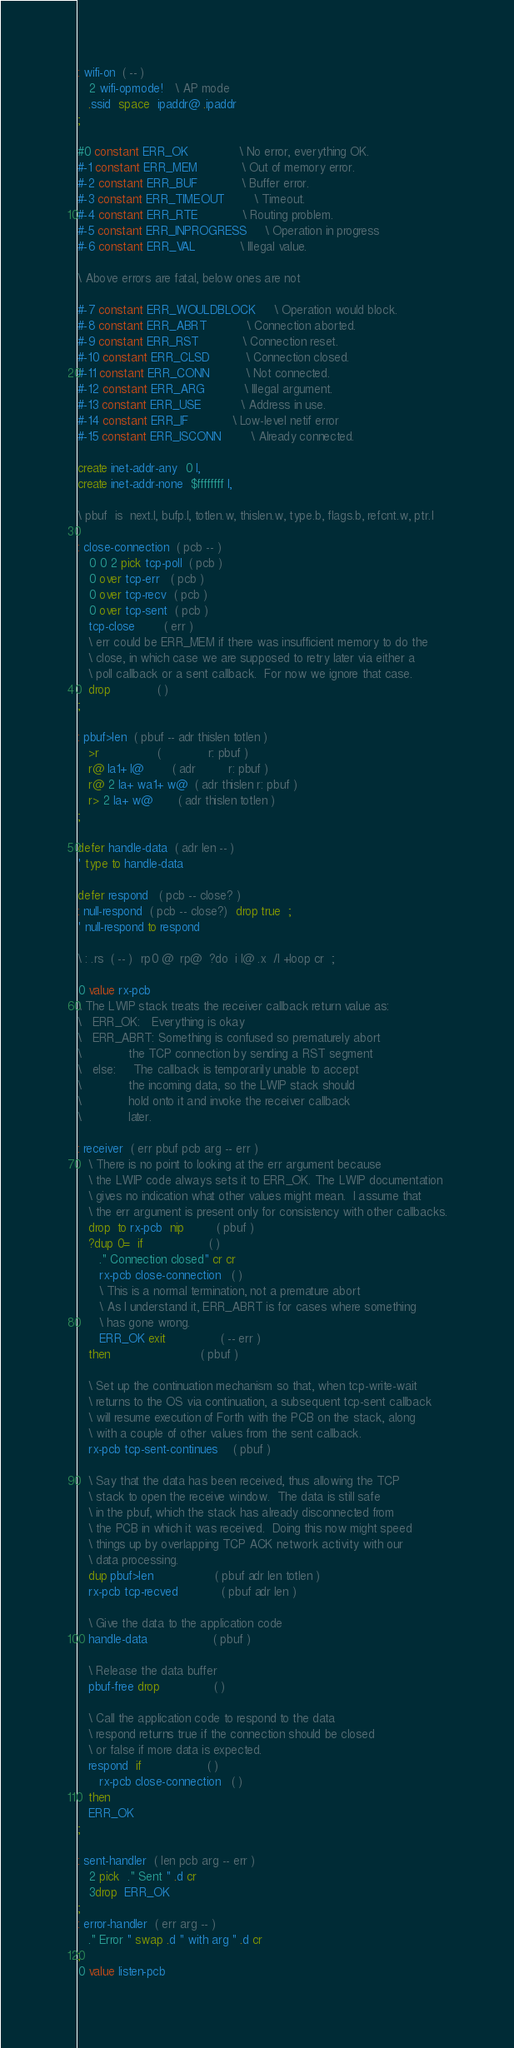Convert code to text. <code><loc_0><loc_0><loc_500><loc_500><_Forth_>: wifi-on  ( -- )
   2 wifi-opmode!   \ AP mode
   .ssid  space  ipaddr@ .ipaddr
;

#0 constant ERR_OK              \ No error, everything OK.
#-1 constant ERR_MEM            \ Out of memory error.
#-2 constant ERR_BUF            \ Buffer error.
#-3 constant ERR_TIMEOUT        \ Timeout.
#-4 constant ERR_RTE            \ Routing problem.
#-5 constant ERR_INPROGRESS     \ Operation in progress
#-6 constant ERR_VAL            \ Illegal value.

\ Above errors are fatal, below ones are not

#-7 constant ERR_WOULDBLOCK     \ Operation would block.
#-8 constant ERR_ABRT           \ Connection aborted.
#-9 constant ERR_RST            \ Connection reset.
#-10 constant ERR_CLSD          \ Connection closed.
#-11 constant ERR_CONN          \ Not connected.
#-12 constant ERR_ARG           \ Illegal argument.
#-13 constant ERR_USE           \ Address in use.
#-14 constant ERR_IF            \ Low-level netif error
#-15 constant ERR_ISCONN        \ Already connected.

create inet-addr-any  0 l,
create inet-addr-none  $ffffffff l,

\ pbuf  is  next.l, bufp.l, totlen.w, thislen.w, type.b, flags.b, refcnt.w, ptr.l

: close-connection  ( pcb -- )
   0 0 2 pick tcp-poll  ( pcb )
   0 over tcp-err   ( pcb )
   0 over tcp-recv  ( pcb )
   0 over tcp-sent  ( pcb )
   tcp-close        ( err )
   \ err could be ERR_MEM if there was insufficient memory to do the
   \ close, in which case we are supposed to retry later via either a
   \ poll callback or a sent callback.  For now we ignore that case.
   drop             ( )
;

: pbuf>len  ( pbuf -- adr thislen totlen )
   >r                (             r: pbuf )
   r@ la1+ l@        ( adr         r: pbuf )
   r@ 2 la+ wa1+ w@  ( adr thislen r: pbuf )
   r> 2 la+ w@       ( adr thislen totlen )
;

defer handle-data  ( adr len -- )
' type to handle-data

defer respond   ( pcb -- close? )
: null-respond  ( pcb -- close?)  drop true  ;
' null-respond to respond

\ : .rs  ( -- )  rp0 @  rp@  ?do  i l@ .x  /l +loop cr  ;

0 value rx-pcb
\ The LWIP stack treats the receiver callback return value as:
\   ERR_OK:   Everything is okay
\   ERR_ABRT: Something is confused so prematurely abort
\             the TCP connection by sending a RST segment
\   else:     The callback is temporarily unable to accept
\             the incoming data, so the LWIP stack should
\             hold onto it and invoke the receiver callback
\             later.

: receiver  ( err pbuf pcb arg -- err )
   \ There is no point to looking at the err argument because
   \ the LWIP code always sets it to ERR_OK. The LWIP documentation
   \ gives no indication what other values might mean.  I assume that
   \ the err argument is present only for consistency with other callbacks.
   drop  to rx-pcb  nip         ( pbuf )
   ?dup 0=  if                  ( )
      ." Connection closed" cr cr
      rx-pcb close-connection   ( )
      \ This is a normal termination, not a premature abort
      \ As I understand it, ERR_ABRT is for cases where something
      \ has gone wrong.
      ERR_OK exit               ( -- err )
   then                         ( pbuf )

   \ Set up the continuation mechanism so that, when tcp-write-wait
   \ returns to the OS via continuation, a subsequent tcp-sent callback
   \ will resume execution of Forth with the PCB on the stack, along
   \ with a couple of other values from the sent callback.
   rx-pcb tcp-sent-continues    ( pbuf )

   \ Say that the data has been received, thus allowing the TCP
   \ stack to open the receive window.  The data is still safe
   \ in the pbuf, which the stack has already disconnected from
   \ the PCB in which it was received.  Doing this now might speed
   \ things up by overlapping TCP ACK network activity with our
   \ data processing.
   dup pbuf>len                 ( pbuf adr len totlen )
   rx-pcb tcp-recved            ( pbuf adr len )

   \ Give the data to the application code
   handle-data                  ( pbuf )

   \ Release the data buffer
   pbuf-free drop               ( )

   \ Call the application code to respond to the data
   \ respond returns true if the connection should be closed
   \ or false if more data is expected.
   respond  if                  ( )
      rx-pcb close-connection   ( )
   then
   ERR_OK
;

: sent-handler  ( len pcb arg -- err )
   2 pick  ." Sent " .d cr
   3drop  ERR_OK
;
: error-handler  ( err arg -- )
   ." Error " swap .d " with arg " .d cr
;
0 value listen-pcb</code> 